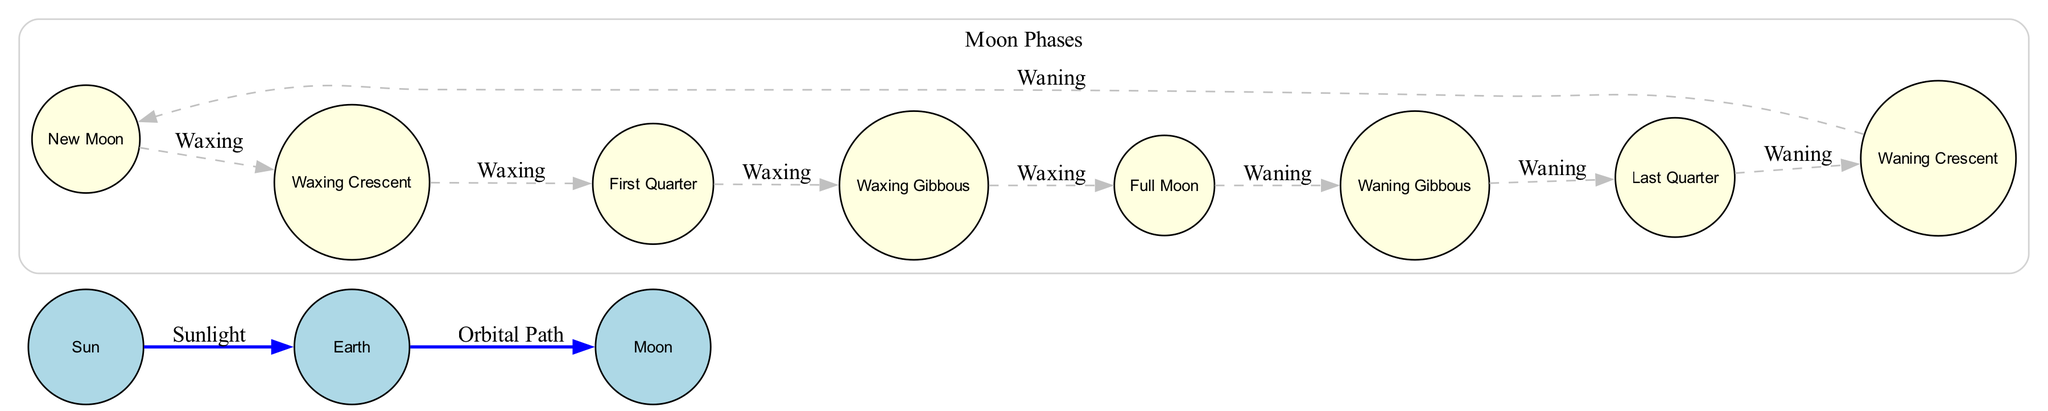What are the main celestial bodies depicted in the diagram? The diagram includes three main celestial bodies: the Sun, Earth, and Moon, which are represented as nodes. Each of these bodies plays a significant role in the phases of the Moon, where the Sun provides light, Earth observes the Moon, and the Moon reflects sunlight.
Answer: Sun, Earth, Moon How many phases of the Moon are illustrated in the diagram? The diagram illustrates a total of eight distinct phases of the Moon. These phases include New Moon, Waxing Crescent, First Quarter, Waxing Gibbous, Full Moon, Waning Gibbous, Last Quarter, and Waning Crescent, which can be counted directly from the nodes presented.
Answer: Eight Which phase comes immediately after New Moon? After New Moon, the next phase visible is the Waxing Crescent. This is indicated by the flow from the New Moon node to the Waxing Crescent node in the diagram, showing that Waxing represents the progression of phases.
Answer: Waxing Crescent What does the arrow labeled "Sunlight" indicate in the diagram? The arrow labeled "Sunlight" represents the illumination provided by the Sun to the Earth and subsequently affects the visibility of the Moon as it goes through its phases. It connects the Sun to the Earth, emphasizing its role as the light source.
Answer: Illumination During which Moon phase is the entire face of the Moon illuminated? The Full Moon phase is when the entire face of the Moon is illuminated. This can be determined from the node labeled Full Moon, which is directly connected to the previous phase (Waxing Gibbous) and shows the maximum visibility of the Moon from Earth.
Answer: Full Moon How does the phase transition from Waxing Crescent to First Quarter occur? The transition from Waxing Crescent to First Quarter, indicated by the arrow labeled "Waxing," signifies the gradual increase in visibility of the Moon, whereby more than a quarter of the Moon is illuminated leading up to the First Quarter phase. The term "Waxing" implies increasing illumination.
Answer: Waxing What is the direction of the Moon's phases progression in the diagram? The progression of the Moon's phases moves in a clockwise direction starting from New Moon, through Waxing phases to Full Moon, and then through Waning phases back to New Moon. This cyclical flow is illustrated by the sequenced nodes connected by arrows.
Answer: Clockwise Which phase directly follows the Full Moon? The phase that follows the Full Moon is the Waning Gibbous, representing a decrease in illumination. This relationship can be observed by the arrow labeled "Waning" that directs from Full Moon to Waning Gibbous in the diagram.
Answer: Waning Gibbous 